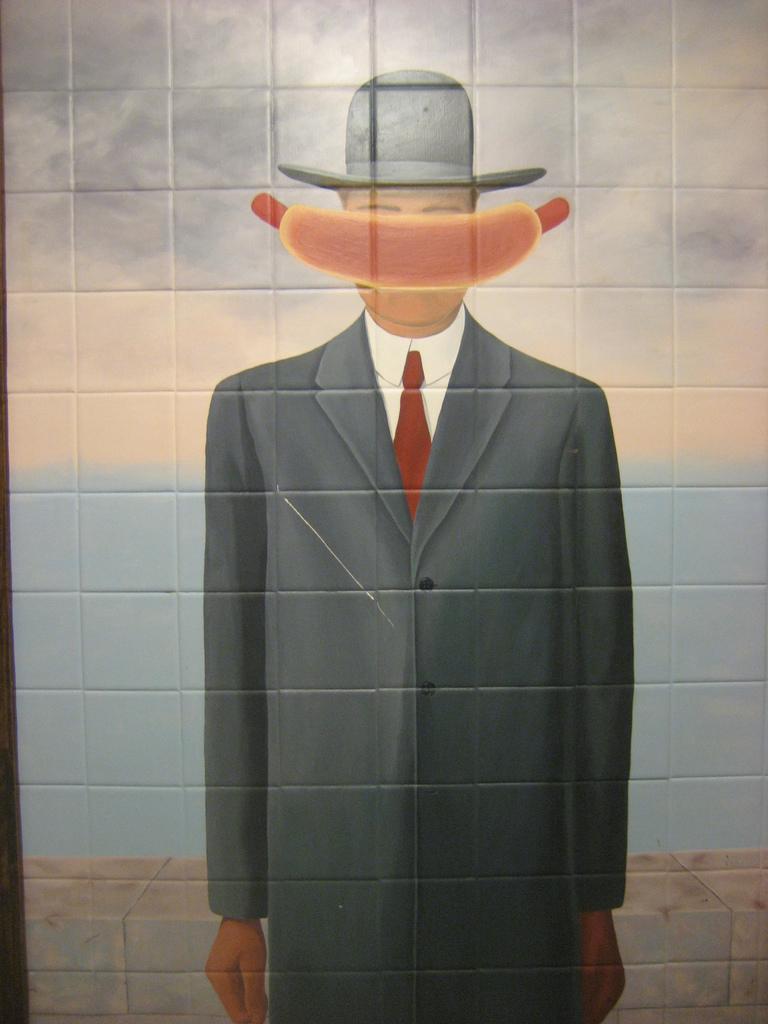How would you summarize this image in a sentence or two? In this picture I can see painting of a human on the wall. 